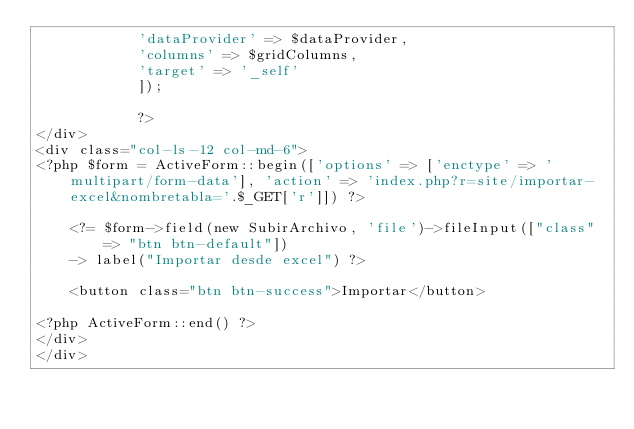<code> <loc_0><loc_0><loc_500><loc_500><_PHP_>            'dataProvider' => $dataProvider,
            'columns' => $gridColumns,
            'target' => '_self'
            ]);

            ?>
</div>
<div class="col-ls-12 col-md-6">
<?php $form = ActiveForm::begin(['options' => ['enctype' => 'multipart/form-data'], 'action' => 'index.php?r=site/importar-excel&nombretabla='.$_GET['r']]) ?>

    <?= $form->field(new SubirArchivo, 'file')->fileInput(["class" => "btn btn-default"]) 
    -> label("Importar desde excel") ?>

    <button class="btn btn-success">Importar</button>

<?php ActiveForm::end() ?>
</div>
</div>
</code> 